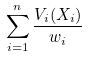<formula> <loc_0><loc_0><loc_500><loc_500>\sum _ { i = 1 } ^ { n } \frac { V _ { i } ( X _ { i } ) } { w _ { i } }</formula> 